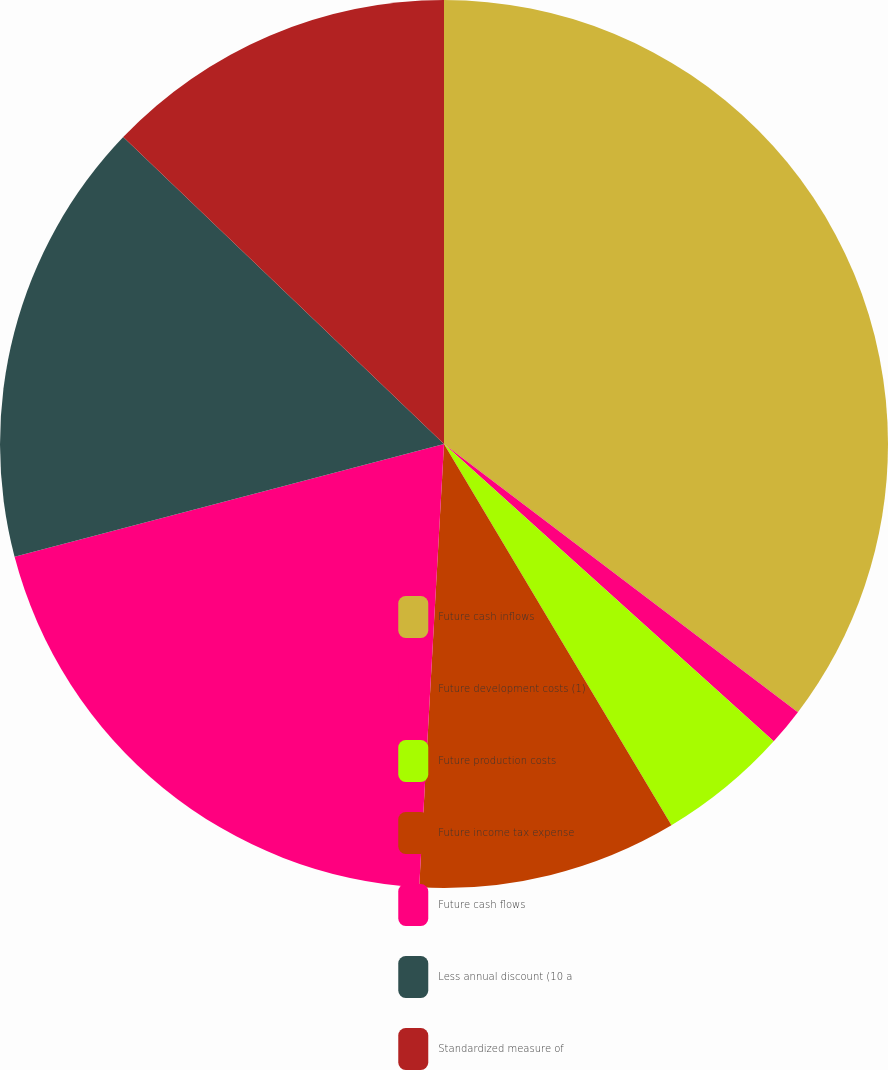<chart> <loc_0><loc_0><loc_500><loc_500><pie_chart><fcel>Future cash inflows<fcel>Future development costs (1)<fcel>Future production costs<fcel>Future income tax expense<fcel>Future cash flows<fcel>Less annual discount (10 a<fcel>Standardized measure of<nl><fcel>35.32%<fcel>1.36%<fcel>4.76%<fcel>9.45%<fcel>20.02%<fcel>16.24%<fcel>12.85%<nl></chart> 